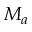<formula> <loc_0><loc_0><loc_500><loc_500>M _ { a }</formula> 